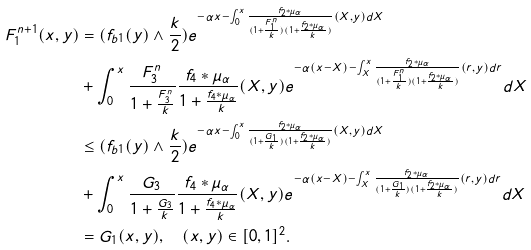Convert formula to latex. <formula><loc_0><loc_0><loc_500><loc_500>F _ { 1 } ^ { n + 1 } ( x , y ) & = ( f _ { b 1 } ( y ) \wedge \frac { k } { 2 } ) e ^ { - \alpha x - \int _ { 0 } ^ { x } \frac { f _ { 2 } \ast \mu _ { \alpha } } { ( 1 + \frac { F ^ { n } _ { 1 } } { k } ) ( 1 + \frac { f _ { 2 } \ast \mu _ { \alpha } } { k } ) } ( X , y ) d X } \\ & + \int _ { 0 } ^ { x } \frac { F _ { 3 } ^ { n } } { 1 + \frac { F _ { 3 } ^ { n } } { k } } \frac { f _ { 4 } \ast \mu _ { \alpha } } { 1 + \frac { f _ { 4 } \ast \mu _ { \alpha } } { k } } ( X , y ) e ^ { - \alpha ( x - X ) - \int _ { X } ^ { x } \frac { f _ { 2 } \ast \mu _ { \alpha } } { ( 1 + \frac { F ^ { n } _ { 1 } } { k } ) ( 1 + \frac { f _ { 2 } \ast \mu _ { \alpha } } { k } ) } ( r , y ) d r } d X \\ & \leq ( f _ { b 1 } ( y ) \wedge \frac { k } { 2 } ) e ^ { - \alpha x - \int _ { 0 } ^ { x } \frac { f _ { 2 } \ast \mu _ { \alpha } } { ( 1 + \frac { G _ { 1 } } { k } ) ( 1 + \frac { f _ { 2 } \ast \mu _ { \alpha } } { k } ) } ( X , y ) d X } \\ & + \int _ { 0 } ^ { x } \frac { G _ { 3 } } { 1 + \frac { G _ { 3 } } { k } } \frac { f _ { 4 } \ast \mu _ { \alpha } } { 1 + \frac { f _ { 4 } \ast \mu _ { \alpha } } { k } } ( X , y ) e ^ { - \alpha ( x - X ) - \int _ { X } ^ { x } \frac { f _ { 2 } \ast \mu _ { \alpha } } { ( 1 + \frac { G _ { 1 } } { k } ) ( 1 + \frac { f _ { 2 } \ast \mu _ { \alpha } } { k } ) } ( r , y ) d r } d X \\ & = G _ { 1 } ( x , y ) , \quad ( x , y ) \in [ 0 , 1 ] ^ { 2 } .</formula> 